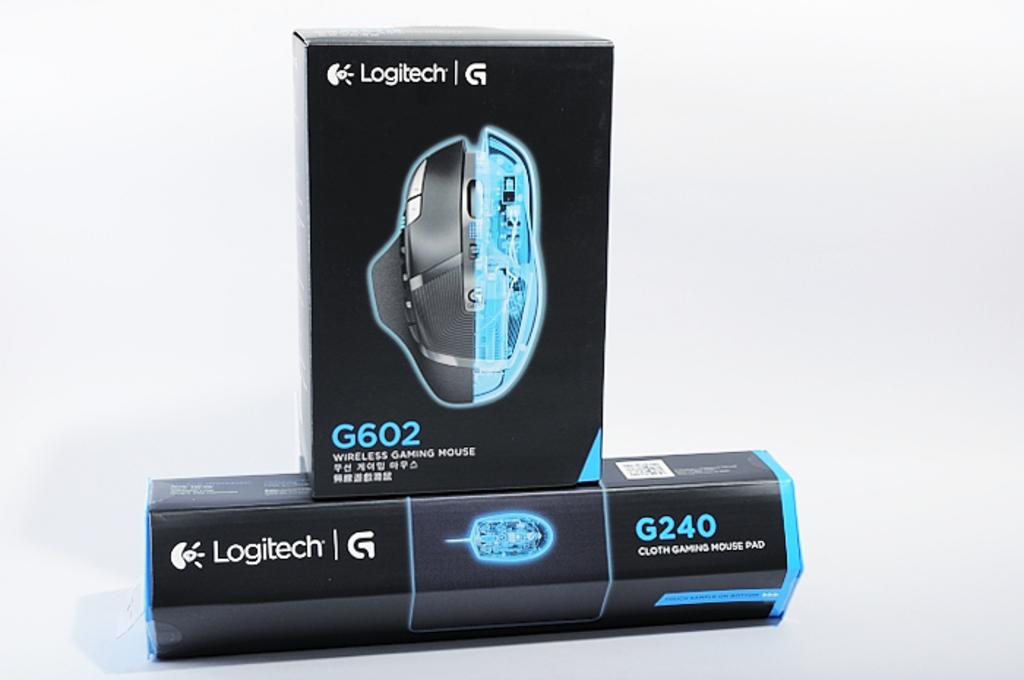How many boxes are present in the image? There are two boxes in the image. What is depicted on the boxes? The boxes have pictures of a mouse. What else can be seen on the boxes besides the mouse picture? There is text and numbers on the boxes. What type of sponge is being used to clean the boxes in the image? There is no sponge present in the image, nor is there any indication of cleaning. 